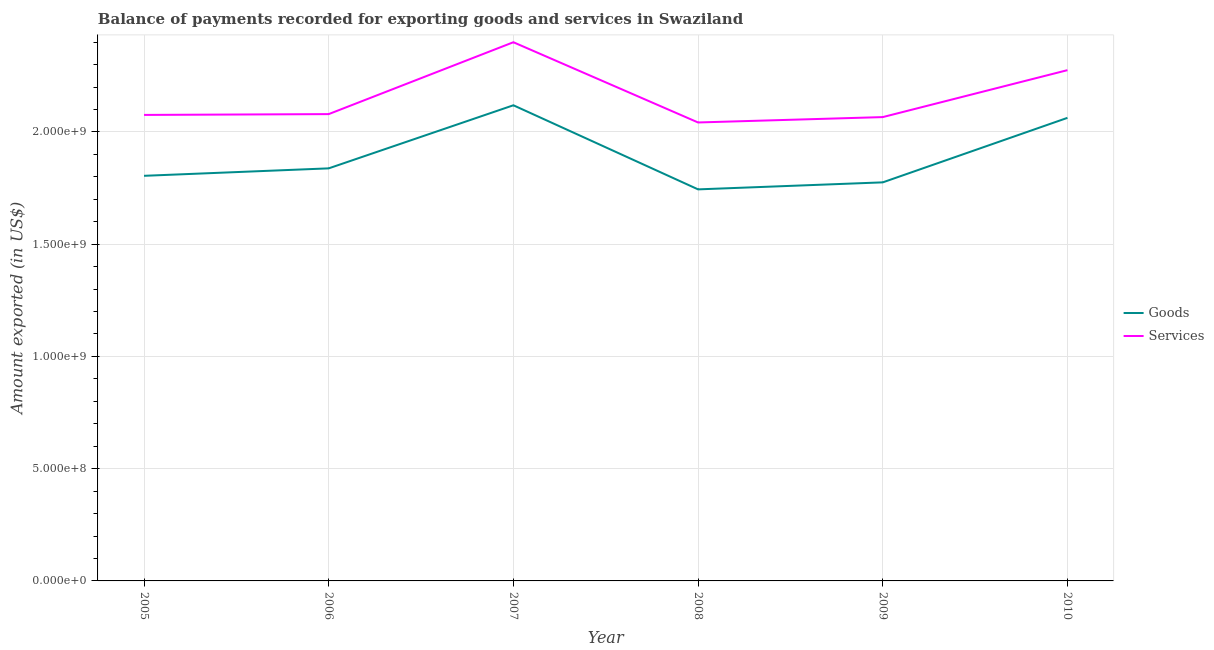How many different coloured lines are there?
Offer a terse response. 2. Does the line corresponding to amount of services exported intersect with the line corresponding to amount of goods exported?
Provide a short and direct response. No. Is the number of lines equal to the number of legend labels?
Ensure brevity in your answer.  Yes. What is the amount of goods exported in 2006?
Make the answer very short. 1.84e+09. Across all years, what is the maximum amount of services exported?
Offer a terse response. 2.40e+09. Across all years, what is the minimum amount of services exported?
Keep it short and to the point. 2.04e+09. In which year was the amount of goods exported minimum?
Your answer should be very brief. 2008. What is the total amount of goods exported in the graph?
Offer a terse response. 1.13e+1. What is the difference between the amount of goods exported in 2007 and that in 2010?
Provide a succinct answer. 5.61e+07. What is the difference between the amount of services exported in 2007 and the amount of goods exported in 2005?
Offer a very short reply. 5.95e+08. What is the average amount of services exported per year?
Keep it short and to the point. 2.16e+09. In the year 2007, what is the difference between the amount of services exported and amount of goods exported?
Your answer should be compact. 2.81e+08. In how many years, is the amount of services exported greater than 1400000000 US$?
Your response must be concise. 6. What is the ratio of the amount of goods exported in 2005 to that in 2008?
Your answer should be compact. 1.03. Is the amount of services exported in 2005 less than that in 2008?
Give a very brief answer. No. What is the difference between the highest and the second highest amount of goods exported?
Your answer should be compact. 5.61e+07. What is the difference between the highest and the lowest amount of services exported?
Offer a very short reply. 3.57e+08. In how many years, is the amount of goods exported greater than the average amount of goods exported taken over all years?
Offer a terse response. 2. Is the sum of the amount of services exported in 2007 and 2010 greater than the maximum amount of goods exported across all years?
Make the answer very short. Yes. Does the amount of services exported monotonically increase over the years?
Keep it short and to the point. No. Is the amount of services exported strictly greater than the amount of goods exported over the years?
Your response must be concise. Yes. Is the amount of goods exported strictly less than the amount of services exported over the years?
Offer a terse response. Yes. How many years are there in the graph?
Keep it short and to the point. 6. What is the difference between two consecutive major ticks on the Y-axis?
Offer a very short reply. 5.00e+08. Does the graph contain grids?
Offer a terse response. Yes. Where does the legend appear in the graph?
Offer a very short reply. Center right. How many legend labels are there?
Offer a terse response. 2. What is the title of the graph?
Your answer should be very brief. Balance of payments recorded for exporting goods and services in Swaziland. Does "Domestic liabilities" appear as one of the legend labels in the graph?
Make the answer very short. No. What is the label or title of the X-axis?
Offer a very short reply. Year. What is the label or title of the Y-axis?
Ensure brevity in your answer.  Amount exported (in US$). What is the Amount exported (in US$) of Goods in 2005?
Keep it short and to the point. 1.80e+09. What is the Amount exported (in US$) in Services in 2005?
Provide a short and direct response. 2.08e+09. What is the Amount exported (in US$) in Goods in 2006?
Provide a short and direct response. 1.84e+09. What is the Amount exported (in US$) of Services in 2006?
Keep it short and to the point. 2.08e+09. What is the Amount exported (in US$) of Goods in 2007?
Offer a very short reply. 2.12e+09. What is the Amount exported (in US$) in Services in 2007?
Provide a short and direct response. 2.40e+09. What is the Amount exported (in US$) of Goods in 2008?
Your response must be concise. 1.74e+09. What is the Amount exported (in US$) in Services in 2008?
Provide a short and direct response. 2.04e+09. What is the Amount exported (in US$) of Goods in 2009?
Give a very brief answer. 1.78e+09. What is the Amount exported (in US$) in Services in 2009?
Your answer should be very brief. 2.07e+09. What is the Amount exported (in US$) of Goods in 2010?
Make the answer very short. 2.06e+09. What is the Amount exported (in US$) in Services in 2010?
Your response must be concise. 2.28e+09. Across all years, what is the maximum Amount exported (in US$) of Goods?
Make the answer very short. 2.12e+09. Across all years, what is the maximum Amount exported (in US$) of Services?
Your answer should be compact. 2.40e+09. Across all years, what is the minimum Amount exported (in US$) of Goods?
Keep it short and to the point. 1.74e+09. Across all years, what is the minimum Amount exported (in US$) in Services?
Your answer should be very brief. 2.04e+09. What is the total Amount exported (in US$) of Goods in the graph?
Offer a very short reply. 1.13e+1. What is the total Amount exported (in US$) in Services in the graph?
Your answer should be very brief. 1.29e+1. What is the difference between the Amount exported (in US$) of Goods in 2005 and that in 2006?
Offer a terse response. -3.32e+07. What is the difference between the Amount exported (in US$) of Services in 2005 and that in 2006?
Provide a succinct answer. -3.61e+06. What is the difference between the Amount exported (in US$) of Goods in 2005 and that in 2007?
Keep it short and to the point. -3.14e+08. What is the difference between the Amount exported (in US$) of Services in 2005 and that in 2007?
Make the answer very short. -3.24e+08. What is the difference between the Amount exported (in US$) in Goods in 2005 and that in 2008?
Make the answer very short. 6.04e+07. What is the difference between the Amount exported (in US$) in Services in 2005 and that in 2008?
Provide a short and direct response. 3.37e+07. What is the difference between the Amount exported (in US$) of Goods in 2005 and that in 2009?
Ensure brevity in your answer.  2.92e+07. What is the difference between the Amount exported (in US$) in Services in 2005 and that in 2009?
Provide a short and direct response. 9.71e+06. What is the difference between the Amount exported (in US$) of Goods in 2005 and that in 2010?
Provide a succinct answer. -2.58e+08. What is the difference between the Amount exported (in US$) in Services in 2005 and that in 2010?
Your answer should be compact. -1.99e+08. What is the difference between the Amount exported (in US$) in Goods in 2006 and that in 2007?
Make the answer very short. -2.81e+08. What is the difference between the Amount exported (in US$) in Services in 2006 and that in 2007?
Keep it short and to the point. -3.20e+08. What is the difference between the Amount exported (in US$) in Goods in 2006 and that in 2008?
Make the answer very short. 9.36e+07. What is the difference between the Amount exported (in US$) in Services in 2006 and that in 2008?
Your answer should be very brief. 3.73e+07. What is the difference between the Amount exported (in US$) of Goods in 2006 and that in 2009?
Keep it short and to the point. 6.24e+07. What is the difference between the Amount exported (in US$) in Services in 2006 and that in 2009?
Provide a short and direct response. 1.33e+07. What is the difference between the Amount exported (in US$) in Goods in 2006 and that in 2010?
Provide a succinct answer. -2.25e+08. What is the difference between the Amount exported (in US$) in Services in 2006 and that in 2010?
Make the answer very short. -1.96e+08. What is the difference between the Amount exported (in US$) of Goods in 2007 and that in 2008?
Your response must be concise. 3.75e+08. What is the difference between the Amount exported (in US$) of Services in 2007 and that in 2008?
Provide a short and direct response. 3.57e+08. What is the difference between the Amount exported (in US$) in Goods in 2007 and that in 2009?
Keep it short and to the point. 3.43e+08. What is the difference between the Amount exported (in US$) in Services in 2007 and that in 2009?
Make the answer very short. 3.33e+08. What is the difference between the Amount exported (in US$) in Goods in 2007 and that in 2010?
Your answer should be very brief. 5.61e+07. What is the difference between the Amount exported (in US$) of Services in 2007 and that in 2010?
Your response must be concise. 1.24e+08. What is the difference between the Amount exported (in US$) in Goods in 2008 and that in 2009?
Offer a terse response. -3.12e+07. What is the difference between the Amount exported (in US$) in Services in 2008 and that in 2009?
Give a very brief answer. -2.40e+07. What is the difference between the Amount exported (in US$) of Goods in 2008 and that in 2010?
Give a very brief answer. -3.19e+08. What is the difference between the Amount exported (in US$) of Services in 2008 and that in 2010?
Keep it short and to the point. -2.33e+08. What is the difference between the Amount exported (in US$) in Goods in 2009 and that in 2010?
Keep it short and to the point. -2.87e+08. What is the difference between the Amount exported (in US$) of Services in 2009 and that in 2010?
Give a very brief answer. -2.09e+08. What is the difference between the Amount exported (in US$) in Goods in 2005 and the Amount exported (in US$) in Services in 2006?
Offer a terse response. -2.75e+08. What is the difference between the Amount exported (in US$) in Goods in 2005 and the Amount exported (in US$) in Services in 2007?
Offer a very short reply. -5.95e+08. What is the difference between the Amount exported (in US$) of Goods in 2005 and the Amount exported (in US$) of Services in 2008?
Your response must be concise. -2.38e+08. What is the difference between the Amount exported (in US$) in Goods in 2005 and the Amount exported (in US$) in Services in 2009?
Give a very brief answer. -2.62e+08. What is the difference between the Amount exported (in US$) of Goods in 2005 and the Amount exported (in US$) of Services in 2010?
Your answer should be very brief. -4.71e+08. What is the difference between the Amount exported (in US$) in Goods in 2006 and the Amount exported (in US$) in Services in 2007?
Make the answer very short. -5.62e+08. What is the difference between the Amount exported (in US$) of Goods in 2006 and the Amount exported (in US$) of Services in 2008?
Offer a very short reply. -2.04e+08. What is the difference between the Amount exported (in US$) of Goods in 2006 and the Amount exported (in US$) of Services in 2009?
Your response must be concise. -2.28e+08. What is the difference between the Amount exported (in US$) in Goods in 2006 and the Amount exported (in US$) in Services in 2010?
Make the answer very short. -4.37e+08. What is the difference between the Amount exported (in US$) in Goods in 2007 and the Amount exported (in US$) in Services in 2008?
Provide a succinct answer. 7.66e+07. What is the difference between the Amount exported (in US$) in Goods in 2007 and the Amount exported (in US$) in Services in 2009?
Your answer should be very brief. 5.27e+07. What is the difference between the Amount exported (in US$) in Goods in 2007 and the Amount exported (in US$) in Services in 2010?
Your answer should be very brief. -1.56e+08. What is the difference between the Amount exported (in US$) in Goods in 2008 and the Amount exported (in US$) in Services in 2009?
Provide a succinct answer. -3.22e+08. What is the difference between the Amount exported (in US$) in Goods in 2008 and the Amount exported (in US$) in Services in 2010?
Offer a terse response. -5.31e+08. What is the difference between the Amount exported (in US$) in Goods in 2009 and the Amount exported (in US$) in Services in 2010?
Make the answer very short. -5.00e+08. What is the average Amount exported (in US$) in Goods per year?
Provide a succinct answer. 1.89e+09. What is the average Amount exported (in US$) in Services per year?
Keep it short and to the point. 2.16e+09. In the year 2005, what is the difference between the Amount exported (in US$) in Goods and Amount exported (in US$) in Services?
Keep it short and to the point. -2.71e+08. In the year 2006, what is the difference between the Amount exported (in US$) of Goods and Amount exported (in US$) of Services?
Your answer should be compact. -2.42e+08. In the year 2007, what is the difference between the Amount exported (in US$) in Goods and Amount exported (in US$) in Services?
Keep it short and to the point. -2.81e+08. In the year 2008, what is the difference between the Amount exported (in US$) in Goods and Amount exported (in US$) in Services?
Keep it short and to the point. -2.98e+08. In the year 2009, what is the difference between the Amount exported (in US$) of Goods and Amount exported (in US$) of Services?
Your answer should be compact. -2.91e+08. In the year 2010, what is the difference between the Amount exported (in US$) in Goods and Amount exported (in US$) in Services?
Your answer should be compact. -2.13e+08. What is the ratio of the Amount exported (in US$) of Goods in 2005 to that in 2006?
Your answer should be very brief. 0.98. What is the ratio of the Amount exported (in US$) in Services in 2005 to that in 2006?
Your answer should be very brief. 1. What is the ratio of the Amount exported (in US$) of Goods in 2005 to that in 2007?
Offer a very short reply. 0.85. What is the ratio of the Amount exported (in US$) in Services in 2005 to that in 2007?
Provide a succinct answer. 0.87. What is the ratio of the Amount exported (in US$) in Goods in 2005 to that in 2008?
Your answer should be very brief. 1.03. What is the ratio of the Amount exported (in US$) in Services in 2005 to that in 2008?
Offer a very short reply. 1.02. What is the ratio of the Amount exported (in US$) in Goods in 2005 to that in 2009?
Give a very brief answer. 1.02. What is the ratio of the Amount exported (in US$) of Goods in 2005 to that in 2010?
Make the answer very short. 0.87. What is the ratio of the Amount exported (in US$) in Services in 2005 to that in 2010?
Make the answer very short. 0.91. What is the ratio of the Amount exported (in US$) in Goods in 2006 to that in 2007?
Keep it short and to the point. 0.87. What is the ratio of the Amount exported (in US$) in Services in 2006 to that in 2007?
Keep it short and to the point. 0.87. What is the ratio of the Amount exported (in US$) of Goods in 2006 to that in 2008?
Ensure brevity in your answer.  1.05. What is the ratio of the Amount exported (in US$) of Services in 2006 to that in 2008?
Your response must be concise. 1.02. What is the ratio of the Amount exported (in US$) of Goods in 2006 to that in 2009?
Give a very brief answer. 1.04. What is the ratio of the Amount exported (in US$) in Services in 2006 to that in 2009?
Make the answer very short. 1.01. What is the ratio of the Amount exported (in US$) of Goods in 2006 to that in 2010?
Make the answer very short. 0.89. What is the ratio of the Amount exported (in US$) in Services in 2006 to that in 2010?
Make the answer very short. 0.91. What is the ratio of the Amount exported (in US$) in Goods in 2007 to that in 2008?
Ensure brevity in your answer.  1.21. What is the ratio of the Amount exported (in US$) in Services in 2007 to that in 2008?
Your response must be concise. 1.18. What is the ratio of the Amount exported (in US$) of Goods in 2007 to that in 2009?
Offer a very short reply. 1.19. What is the ratio of the Amount exported (in US$) of Services in 2007 to that in 2009?
Offer a very short reply. 1.16. What is the ratio of the Amount exported (in US$) in Goods in 2007 to that in 2010?
Your answer should be very brief. 1.03. What is the ratio of the Amount exported (in US$) in Services in 2007 to that in 2010?
Give a very brief answer. 1.05. What is the ratio of the Amount exported (in US$) of Goods in 2008 to that in 2009?
Ensure brevity in your answer.  0.98. What is the ratio of the Amount exported (in US$) of Services in 2008 to that in 2009?
Your response must be concise. 0.99. What is the ratio of the Amount exported (in US$) of Goods in 2008 to that in 2010?
Ensure brevity in your answer.  0.85. What is the ratio of the Amount exported (in US$) in Services in 2008 to that in 2010?
Make the answer very short. 0.9. What is the ratio of the Amount exported (in US$) in Goods in 2009 to that in 2010?
Make the answer very short. 0.86. What is the ratio of the Amount exported (in US$) of Services in 2009 to that in 2010?
Make the answer very short. 0.91. What is the difference between the highest and the second highest Amount exported (in US$) in Goods?
Provide a succinct answer. 5.61e+07. What is the difference between the highest and the second highest Amount exported (in US$) of Services?
Your response must be concise. 1.24e+08. What is the difference between the highest and the lowest Amount exported (in US$) of Goods?
Your response must be concise. 3.75e+08. What is the difference between the highest and the lowest Amount exported (in US$) of Services?
Offer a very short reply. 3.57e+08. 